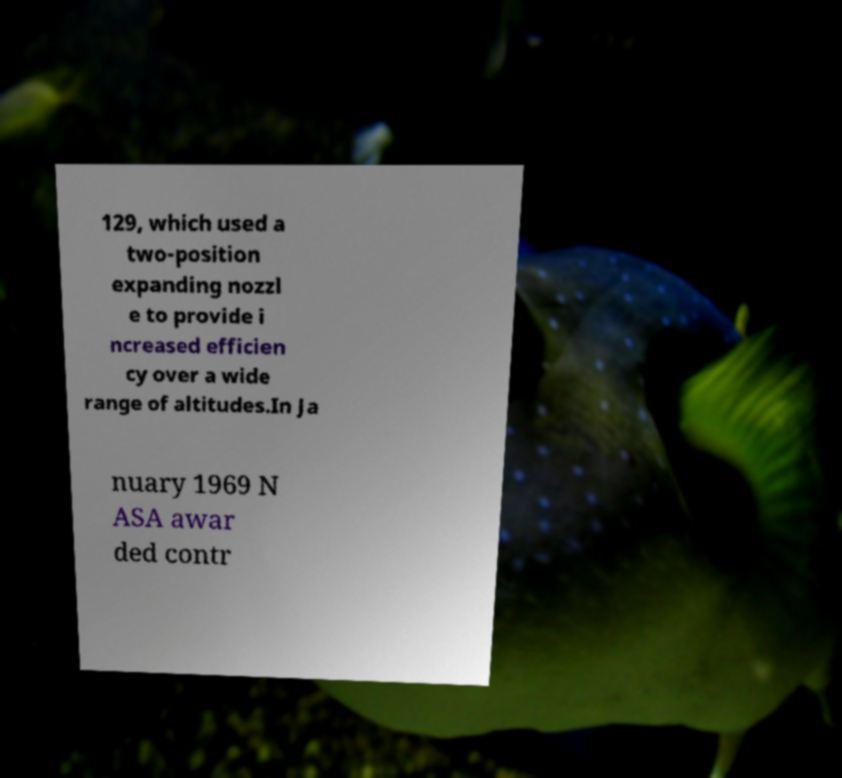For documentation purposes, I need the text within this image transcribed. Could you provide that? 129, which used a two-position expanding nozzl e to provide i ncreased efficien cy over a wide range of altitudes.In Ja nuary 1969 N ASA awar ded contr 